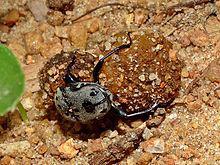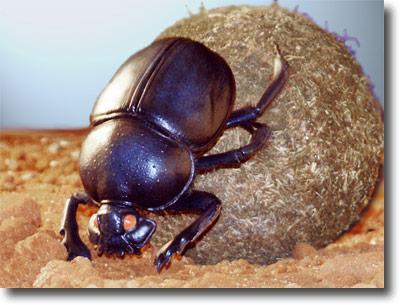The first image is the image on the left, the second image is the image on the right. For the images displayed, is the sentence "Each image includes a beetle in contact with a round dung ball." factually correct? Answer yes or no. Yes. The first image is the image on the left, the second image is the image on the right. For the images shown, is this caption "A beetle is on a dung ball." true? Answer yes or no. Yes. 